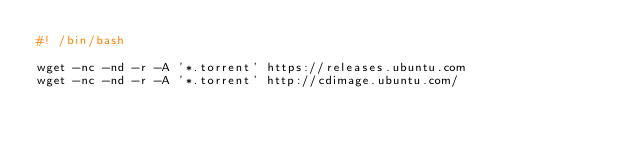Convert code to text. <code><loc_0><loc_0><loc_500><loc_500><_Bash_>#! /bin/bash

wget -nc -nd -r -A '*.torrent' https://releases.ubuntu.com
wget -nc -nd -r -A '*.torrent' http://cdimage.ubuntu.com/
</code> 